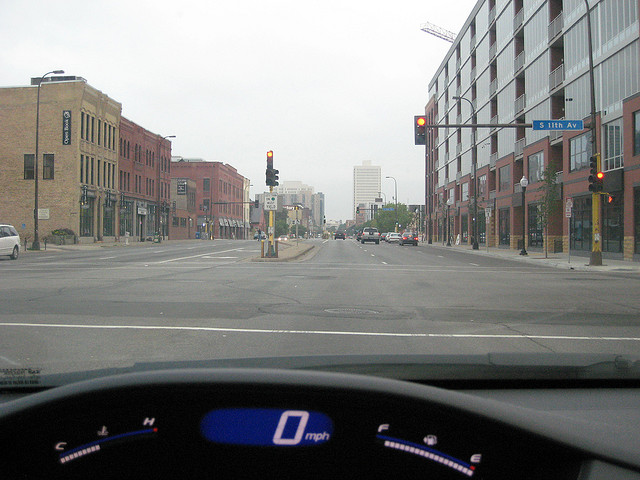<image>When were these stoplights installed in the picture? It is unknown when these stoplights were installed. The information given is too varied to give a specific answer. When were these stoplights installed in the picture? It is ambiguous when these stoplights were installed in the picture. It can be years ago, recently or even in 2015. 